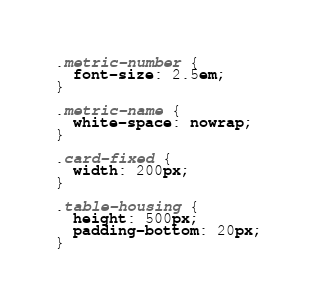Convert code to text. <code><loc_0><loc_0><loc_500><loc_500><_CSS_>.metric-number {
  font-size: 2.5em;
}

.metric-name {
  white-space: nowrap;
}

.card-fixed {
  width: 200px;
}

.table-housing {
  height: 500px;
  padding-bottom: 20px;
}
</code> 